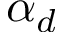<formula> <loc_0><loc_0><loc_500><loc_500>\alpha _ { d }</formula> 